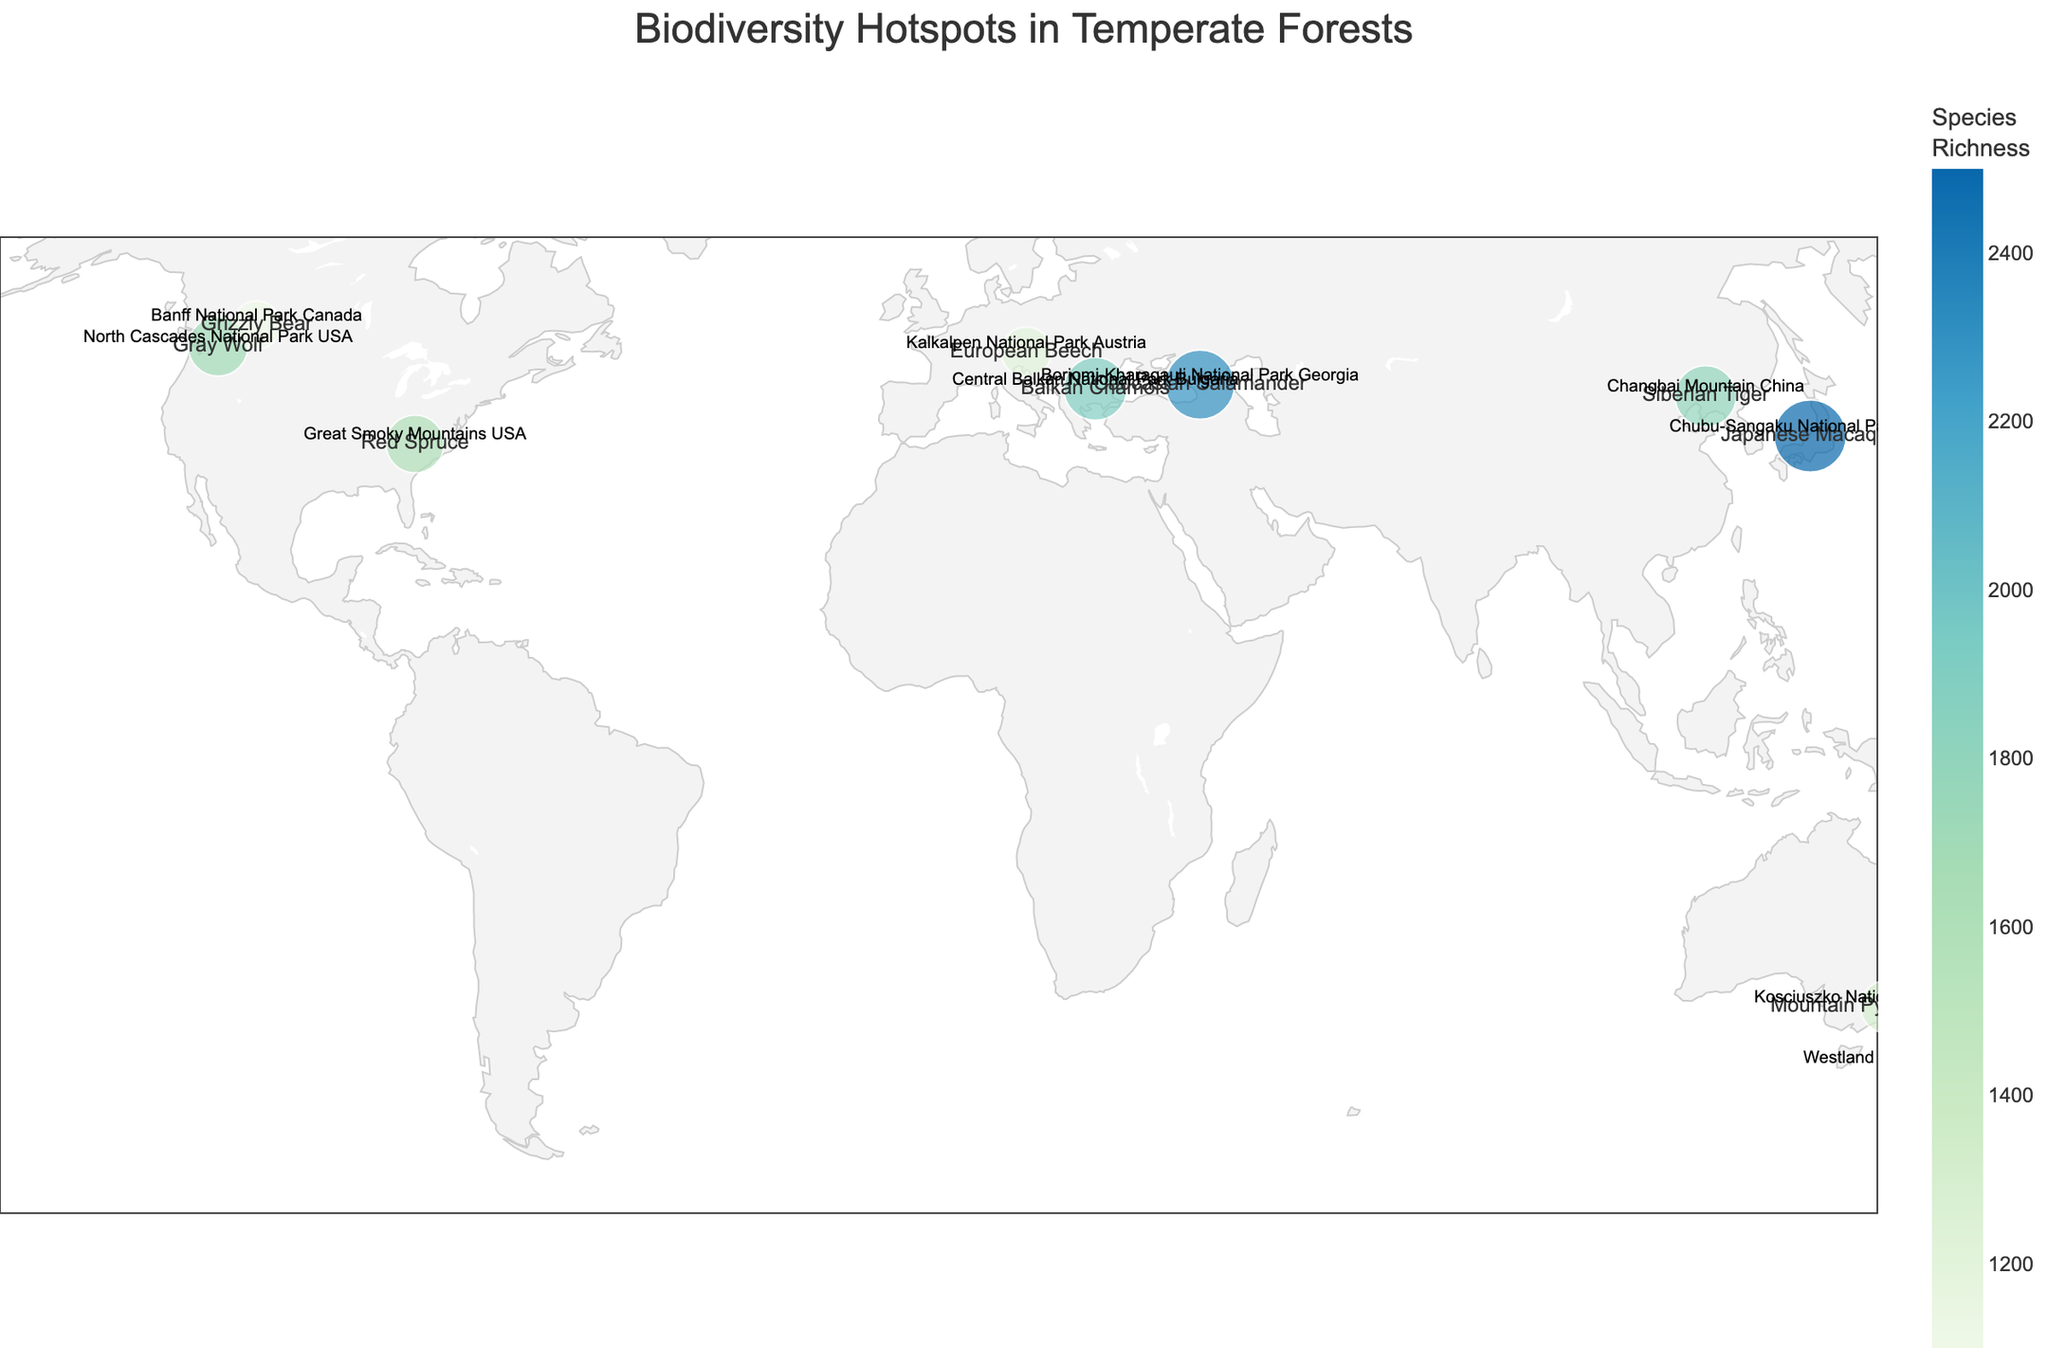what is the title of the plot? The title of the plot is typically placed at the top of the figure in a larger, bold font. Here, the title positioned centrally at the top reads "Biodiversity Hotspots in Temperate Forests".
Answer: Biodiversity Hotspots in Temperate Forests Which location has the highest species richness? By examining the various points on the map, we see that Chubu-Sangaku National Park in Japan has the largest size circle, representing the highest species richness of 2500.
Answer: Chubu-Sangaku National Park Japan How many locations have a species richness greater than 1800? By inspecting the color and size of the circles and referencing the species richness values, we find that three locations have values higher than 1800: Chubu-Sangaku National Park Japan (2500), Borjomi-Kharagauli National Park Georgia (2300), and Central Balkan National Park Bulgaria (1900).
Answer: 3 Compare the species richness between Great Smoky Mountains USA and North Cascades National Park USA. Which one has a higher value? We look at the respective points on the map and their associated values. Great Smoky Mountains USA has a species richness of 1600, while North Cascades National Park USA has a species richness of 1700. North Cascades is higher.
Answer: North Cascades National Park USA What is the common characteristic of all points (locations) on the map in terms of geographical features? All the points are located in temperate forest regions as indicated in the title of the plot. This implies that they are all areas rich in biodiversity within temperate forests.
Answer: Temperate forest regions Calculate the average species richness of the locations shown. To find the average, sum the species richness values: 1200 + 1600 + 2500 + 2300 + 1800 + 1400 + 1700 + 1900 + 1300 + 1100 = 17800. There are 10 locations, so the average is 17800 / 10 = 1780.
Answer: 1780 Identify the location with the lowest species richness and provide its notable species. By analyzing the figure, Banff National Park in Canada has the smallest size circle, indicating the lowest species richness of 1100. Its notable species is the Grizzly Bear.
Answer: Banff National Park Canada, Grizzly Bear What is the notable species in Georgia's Borjomi-Kharagauli National Park? Hovering over the point or referring to the text associated with the location, the notable species in Borjomi-Kharagauli National Park is the Caucasian Salamander.
Answer: Caucasian Salamander Explain the color gradient used in the plot. The color gradient on the map shows species richness, with lighter colors representing lower richness and darker colors representing higher richness. The gradient ranges from a light green to a deep blue.
Answer: Lighter green to deep blue showing increasing species richness 